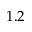Convert formula to latex. <formula><loc_0><loc_0><loc_500><loc_500>1 . 2</formula> 